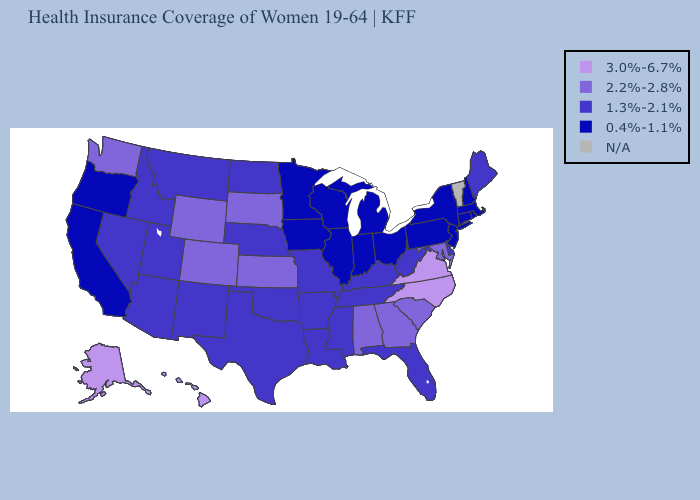What is the value of Arkansas?
Answer briefly. 1.3%-2.1%. What is the lowest value in the Northeast?
Write a very short answer. 0.4%-1.1%. What is the value of Illinois?
Be succinct. 0.4%-1.1%. Name the states that have a value in the range N/A?
Short answer required. Vermont. Does Alaska have the highest value in the USA?
Short answer required. Yes. What is the value of New Jersey?
Keep it brief. 0.4%-1.1%. What is the value of Kentucky?
Give a very brief answer. 1.3%-2.1%. What is the lowest value in the USA?
Concise answer only. 0.4%-1.1%. What is the value of Ohio?
Keep it brief. 0.4%-1.1%. Does Utah have the highest value in the USA?
Keep it brief. No. Among the states that border Alabama , does Georgia have the highest value?
Short answer required. Yes. Which states have the lowest value in the USA?
Answer briefly. California, Connecticut, Illinois, Indiana, Iowa, Massachusetts, Michigan, Minnesota, New Hampshire, New Jersey, New York, Ohio, Oregon, Pennsylvania, Rhode Island, Wisconsin. Name the states that have a value in the range N/A?
Give a very brief answer. Vermont. Does Alaska have the highest value in the West?
Answer briefly. Yes. 